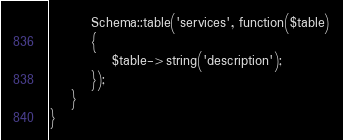Convert code to text. <code><loc_0><loc_0><loc_500><loc_500><_PHP_>        Schema::table('services', function($table)
        {
            $table->string('description');
        });
    }
}
</code> 